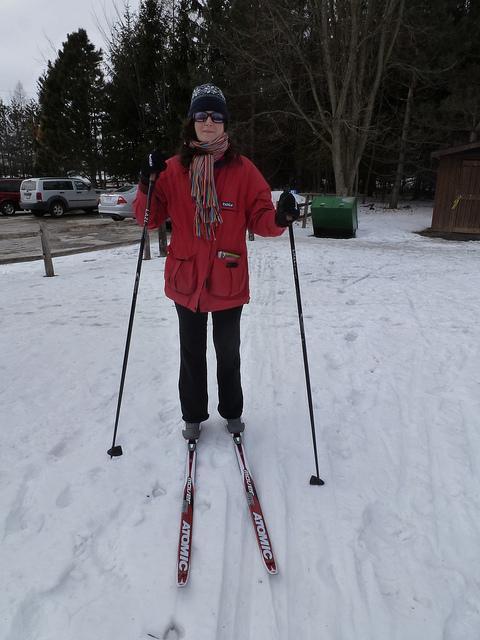Why is the woman wearing the covering around her neck?
Pick the right solution, then justify: 'Answer: answer
Rationale: rationale.'
Options: Keeping warm, covering scar, vanity, style. Answer: keeping warm.
Rationale: The woman is wearing a scarf around her neck to keep her warm in the snowy weather. 